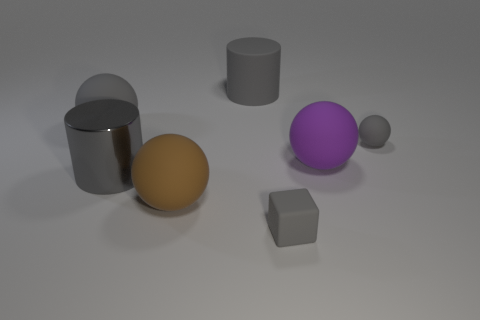How many gray spheres must be subtracted to get 1 gray spheres? 1 Add 3 large gray shiny objects. How many objects exist? 10 Subtract all cylinders. How many objects are left? 5 Subtract all big red rubber objects. Subtract all big purple rubber objects. How many objects are left? 6 Add 6 balls. How many balls are left? 10 Add 2 tiny gray objects. How many tiny gray objects exist? 4 Subtract 0 red spheres. How many objects are left? 7 